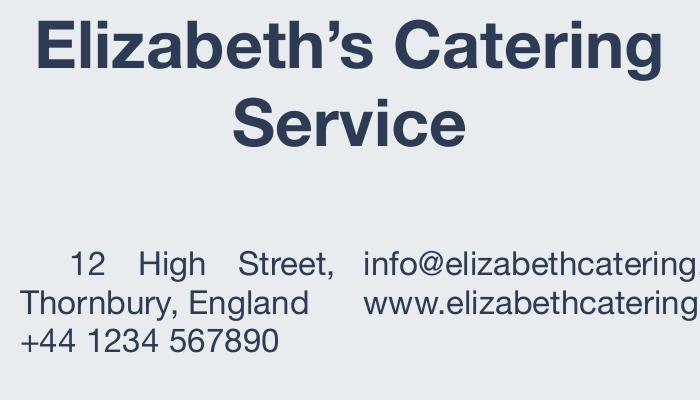What is the name of the catering service? The name of the catering service is prominently displayed at the top of the card.
Answer: Elizabeth's Catering Service What is the contact phone number? The contact phone number is listed near the address section of the card.
Answer: +44 1234 567890 What type of events does the service cater to? The card lists several types of events that the service caters to in a specific section.
Answer: Private Dinners, Corporate Events, Weddings, Birthday Parties, Afternoon Tea, Buffet Service Where is the catering service located? The location is provided with the full address in the contact section.
Answer: 12 High Street, Thornbury, England What is the website for the catering service? The website is also included in the contact details of the card.
Answer: www.elizabethcatering.co.uk What is the font used in the document? The typeface is specified at the beginning of the document.
Answer: Helvetica Neue What is the color theme of the business card? The colors used are defined by their hex values at the start of the document.
Answer: Primary color: #2E3B55, Secondary color: #E9ECEF What is the tagline of the catering service? A tagline is included at the bottom of the card to highlight the service's focus.
Answer: Serving gourmet dishes with meticulous presentation How many services are listed on the card? The number of services is counted from the bullet points presented in the document.
Answer: Six 